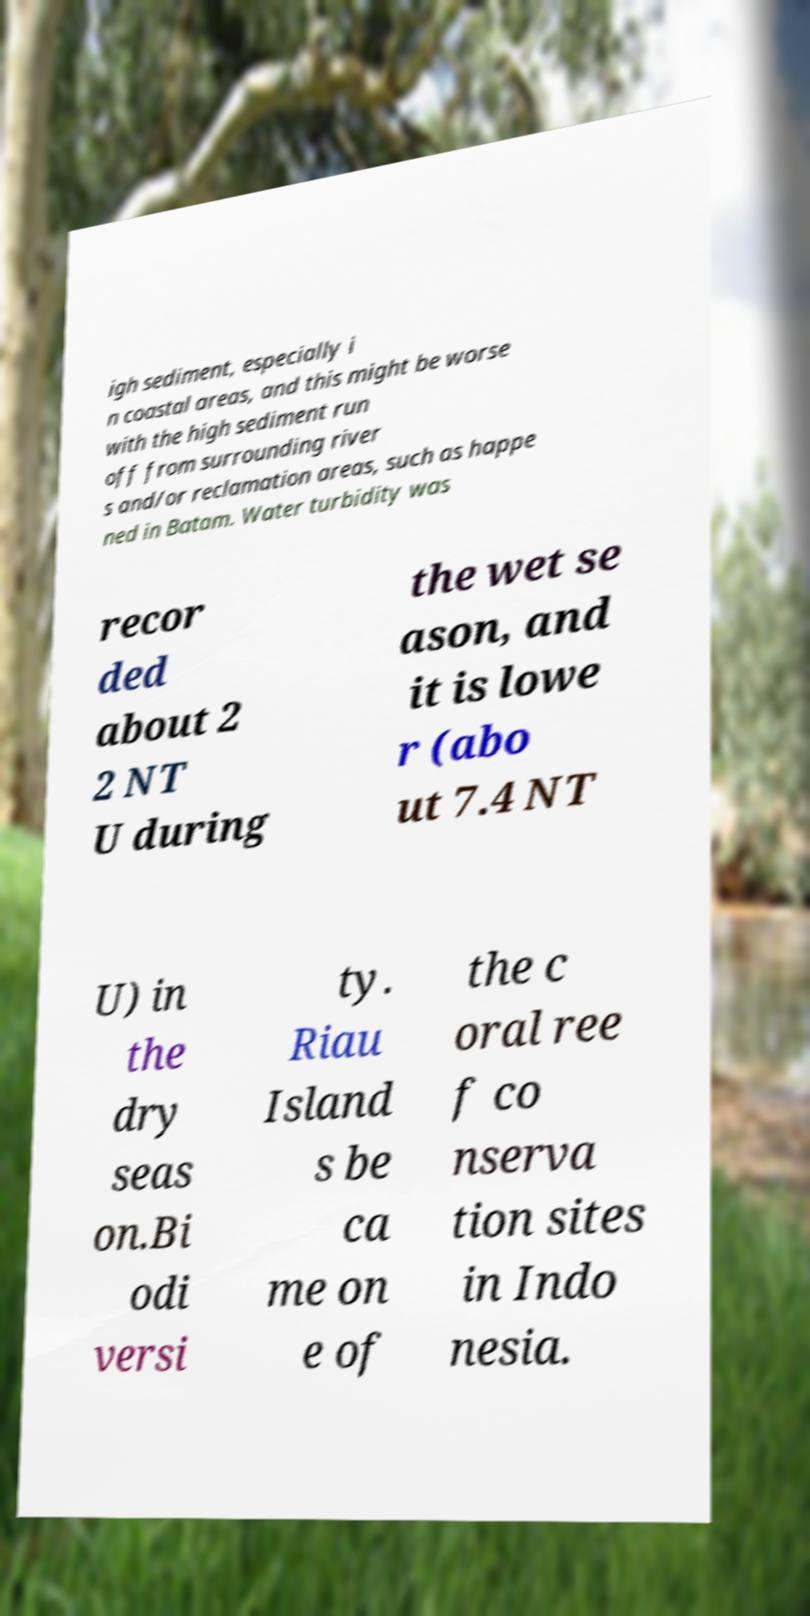Please read and relay the text visible in this image. What does it say? igh sediment, especially i n coastal areas, and this might be worse with the high sediment run off from surrounding river s and/or reclamation areas, such as happe ned in Batam. Water turbidity was recor ded about 2 2 NT U during the wet se ason, and it is lowe r (abo ut 7.4 NT U) in the dry seas on.Bi odi versi ty. Riau Island s be ca me on e of the c oral ree f co nserva tion sites in Indo nesia. 